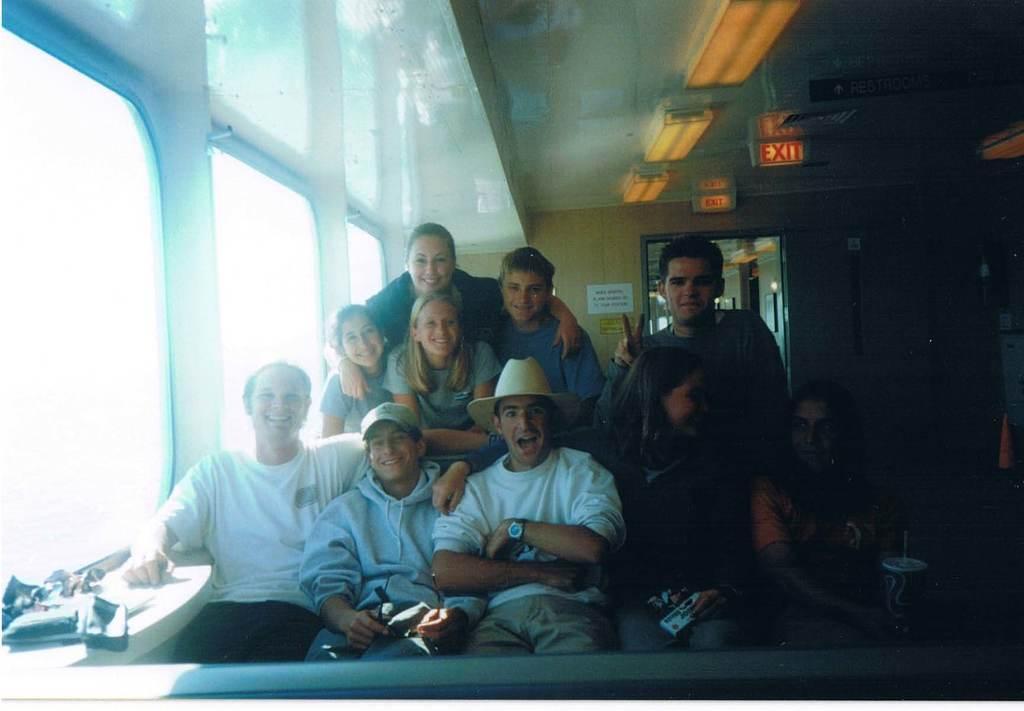Please provide a concise description of this image. In this image there are few people visible inside of the vehicle, at the top there is a sealing on which there is a signboard visible, there is a entrance gate visible in the middle, on the left side there is a window, in front of window few objects visible. 